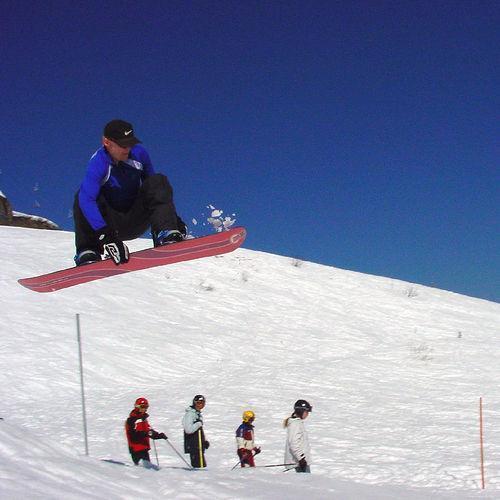How many people are spectating the snowboarder?
Give a very brief answer. 4. 